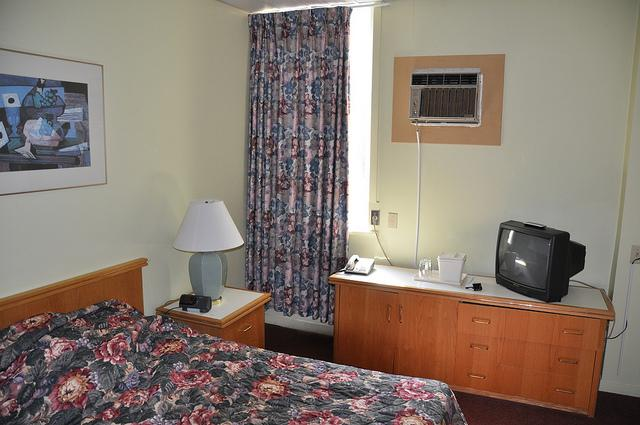What is on the dresser? tv 